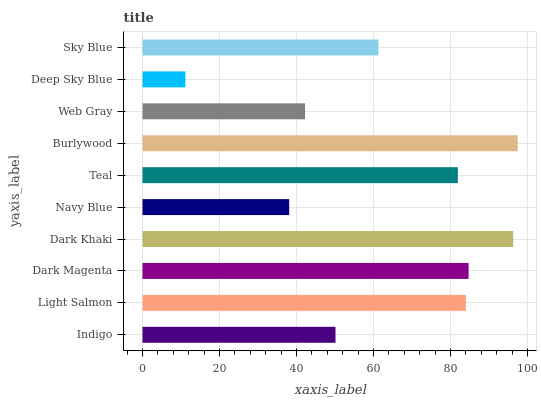Is Deep Sky Blue the minimum?
Answer yes or no. Yes. Is Burlywood the maximum?
Answer yes or no. Yes. Is Light Salmon the minimum?
Answer yes or no. No. Is Light Salmon the maximum?
Answer yes or no. No. Is Light Salmon greater than Indigo?
Answer yes or no. Yes. Is Indigo less than Light Salmon?
Answer yes or no. Yes. Is Indigo greater than Light Salmon?
Answer yes or no. No. Is Light Salmon less than Indigo?
Answer yes or no. No. Is Teal the high median?
Answer yes or no. Yes. Is Sky Blue the low median?
Answer yes or no. Yes. Is Deep Sky Blue the high median?
Answer yes or no. No. Is Light Salmon the low median?
Answer yes or no. No. 